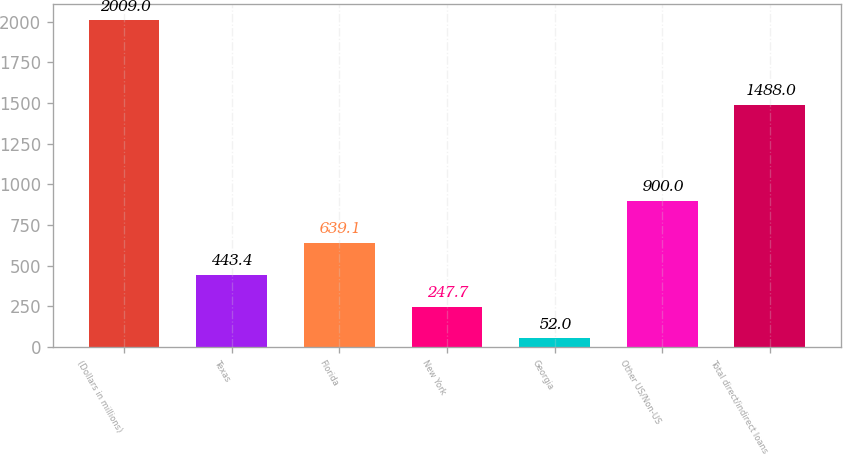Convert chart to OTSL. <chart><loc_0><loc_0><loc_500><loc_500><bar_chart><fcel>(Dollars in millions)<fcel>Texas<fcel>Florida<fcel>New York<fcel>Georgia<fcel>Other US/Non-US<fcel>Total direct/indirect loans<nl><fcel>2009<fcel>443.4<fcel>639.1<fcel>247.7<fcel>52<fcel>900<fcel>1488<nl></chart> 